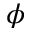Convert formula to latex. <formula><loc_0><loc_0><loc_500><loc_500>\phi</formula> 